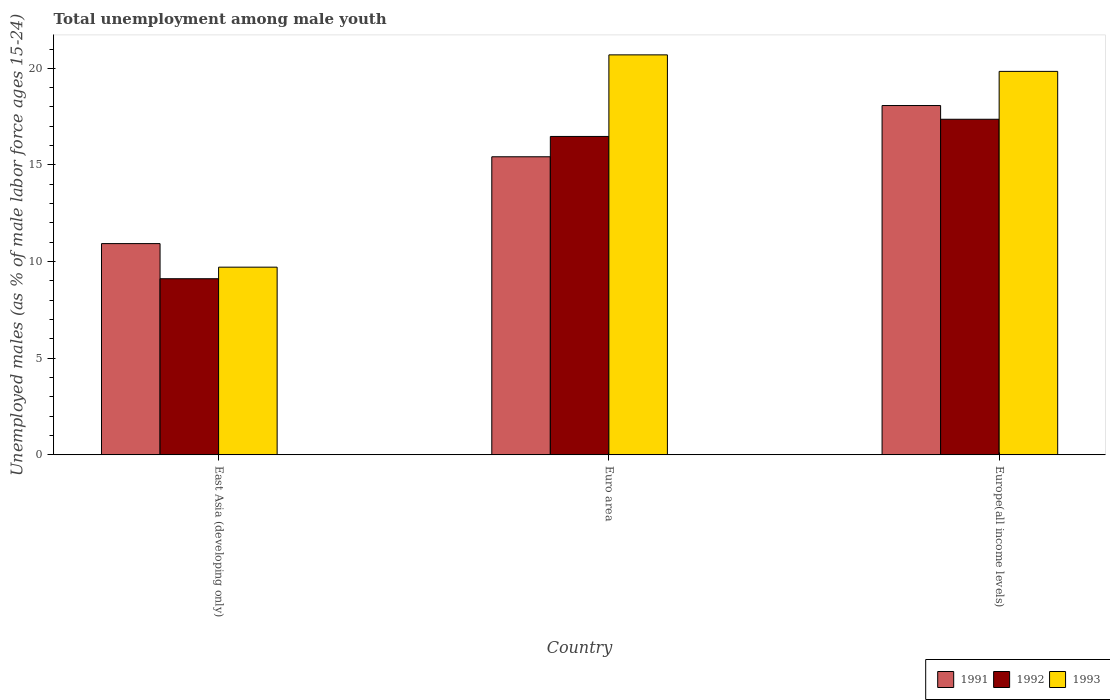How many bars are there on the 3rd tick from the right?
Provide a succinct answer. 3. What is the label of the 3rd group of bars from the left?
Provide a succinct answer. Europe(all income levels). What is the percentage of unemployed males in in 1992 in Euro area?
Your response must be concise. 16.47. Across all countries, what is the maximum percentage of unemployed males in in 1991?
Provide a succinct answer. 18.07. Across all countries, what is the minimum percentage of unemployed males in in 1993?
Provide a succinct answer. 9.71. In which country was the percentage of unemployed males in in 1991 maximum?
Provide a short and direct response. Europe(all income levels). In which country was the percentage of unemployed males in in 1993 minimum?
Your answer should be very brief. East Asia (developing only). What is the total percentage of unemployed males in in 1992 in the graph?
Offer a terse response. 42.95. What is the difference between the percentage of unemployed males in in 1993 in East Asia (developing only) and that in Euro area?
Give a very brief answer. -10.99. What is the difference between the percentage of unemployed males in in 1993 in Euro area and the percentage of unemployed males in in 1991 in Europe(all income levels)?
Offer a terse response. 2.62. What is the average percentage of unemployed males in in 1993 per country?
Ensure brevity in your answer.  16.75. What is the difference between the percentage of unemployed males in of/in 1991 and percentage of unemployed males in of/in 1993 in Euro area?
Offer a terse response. -5.27. In how many countries, is the percentage of unemployed males in in 1993 greater than 6 %?
Provide a succinct answer. 3. What is the ratio of the percentage of unemployed males in in 1991 in East Asia (developing only) to that in Euro area?
Ensure brevity in your answer.  0.71. Is the percentage of unemployed males in in 1991 in East Asia (developing only) less than that in Europe(all income levels)?
Your response must be concise. Yes. What is the difference between the highest and the second highest percentage of unemployed males in in 1993?
Ensure brevity in your answer.  -10.13. What is the difference between the highest and the lowest percentage of unemployed males in in 1992?
Your answer should be compact. 8.25. In how many countries, is the percentage of unemployed males in in 1992 greater than the average percentage of unemployed males in in 1992 taken over all countries?
Offer a very short reply. 2. What does the 1st bar from the left in East Asia (developing only) represents?
Your response must be concise. 1991. How many bars are there?
Your response must be concise. 9. Are all the bars in the graph horizontal?
Offer a terse response. No. Are the values on the major ticks of Y-axis written in scientific E-notation?
Your answer should be compact. No. Does the graph contain any zero values?
Provide a succinct answer. No. Where does the legend appear in the graph?
Provide a short and direct response. Bottom right. How many legend labels are there?
Ensure brevity in your answer.  3. What is the title of the graph?
Provide a short and direct response. Total unemployment among male youth. Does "1961" appear as one of the legend labels in the graph?
Provide a succinct answer. No. What is the label or title of the X-axis?
Your answer should be compact. Country. What is the label or title of the Y-axis?
Give a very brief answer. Unemployed males (as % of male labor force ages 15-24). What is the Unemployed males (as % of male labor force ages 15-24) of 1991 in East Asia (developing only)?
Make the answer very short. 10.93. What is the Unemployed males (as % of male labor force ages 15-24) of 1992 in East Asia (developing only)?
Keep it short and to the point. 9.11. What is the Unemployed males (as % of male labor force ages 15-24) in 1993 in East Asia (developing only)?
Your answer should be compact. 9.71. What is the Unemployed males (as % of male labor force ages 15-24) of 1991 in Euro area?
Your answer should be very brief. 15.42. What is the Unemployed males (as % of male labor force ages 15-24) of 1992 in Euro area?
Make the answer very short. 16.47. What is the Unemployed males (as % of male labor force ages 15-24) of 1993 in Euro area?
Keep it short and to the point. 20.7. What is the Unemployed males (as % of male labor force ages 15-24) of 1991 in Europe(all income levels)?
Keep it short and to the point. 18.07. What is the Unemployed males (as % of male labor force ages 15-24) of 1992 in Europe(all income levels)?
Keep it short and to the point. 17.36. What is the Unemployed males (as % of male labor force ages 15-24) of 1993 in Europe(all income levels)?
Give a very brief answer. 19.84. Across all countries, what is the maximum Unemployed males (as % of male labor force ages 15-24) of 1991?
Provide a short and direct response. 18.07. Across all countries, what is the maximum Unemployed males (as % of male labor force ages 15-24) in 1992?
Your response must be concise. 17.36. Across all countries, what is the maximum Unemployed males (as % of male labor force ages 15-24) of 1993?
Provide a succinct answer. 20.7. Across all countries, what is the minimum Unemployed males (as % of male labor force ages 15-24) of 1991?
Your response must be concise. 10.93. Across all countries, what is the minimum Unemployed males (as % of male labor force ages 15-24) of 1992?
Provide a succinct answer. 9.11. Across all countries, what is the minimum Unemployed males (as % of male labor force ages 15-24) of 1993?
Provide a short and direct response. 9.71. What is the total Unemployed males (as % of male labor force ages 15-24) of 1991 in the graph?
Keep it short and to the point. 44.43. What is the total Unemployed males (as % of male labor force ages 15-24) in 1992 in the graph?
Offer a very short reply. 42.95. What is the total Unemployed males (as % of male labor force ages 15-24) of 1993 in the graph?
Keep it short and to the point. 50.25. What is the difference between the Unemployed males (as % of male labor force ages 15-24) in 1991 in East Asia (developing only) and that in Euro area?
Offer a very short reply. -4.49. What is the difference between the Unemployed males (as % of male labor force ages 15-24) of 1992 in East Asia (developing only) and that in Euro area?
Make the answer very short. -7.36. What is the difference between the Unemployed males (as % of male labor force ages 15-24) in 1993 in East Asia (developing only) and that in Euro area?
Provide a succinct answer. -10.99. What is the difference between the Unemployed males (as % of male labor force ages 15-24) of 1991 in East Asia (developing only) and that in Europe(all income levels)?
Your answer should be compact. -7.14. What is the difference between the Unemployed males (as % of male labor force ages 15-24) of 1992 in East Asia (developing only) and that in Europe(all income levels)?
Give a very brief answer. -8.25. What is the difference between the Unemployed males (as % of male labor force ages 15-24) of 1993 in East Asia (developing only) and that in Europe(all income levels)?
Provide a succinct answer. -10.13. What is the difference between the Unemployed males (as % of male labor force ages 15-24) in 1991 in Euro area and that in Europe(all income levels)?
Your response must be concise. -2.65. What is the difference between the Unemployed males (as % of male labor force ages 15-24) in 1992 in Euro area and that in Europe(all income levels)?
Your answer should be very brief. -0.89. What is the difference between the Unemployed males (as % of male labor force ages 15-24) in 1993 in Euro area and that in Europe(all income levels)?
Provide a succinct answer. 0.85. What is the difference between the Unemployed males (as % of male labor force ages 15-24) of 1991 in East Asia (developing only) and the Unemployed males (as % of male labor force ages 15-24) of 1992 in Euro area?
Your answer should be compact. -5.55. What is the difference between the Unemployed males (as % of male labor force ages 15-24) of 1991 in East Asia (developing only) and the Unemployed males (as % of male labor force ages 15-24) of 1993 in Euro area?
Your response must be concise. -9.77. What is the difference between the Unemployed males (as % of male labor force ages 15-24) of 1992 in East Asia (developing only) and the Unemployed males (as % of male labor force ages 15-24) of 1993 in Euro area?
Your answer should be very brief. -11.58. What is the difference between the Unemployed males (as % of male labor force ages 15-24) of 1991 in East Asia (developing only) and the Unemployed males (as % of male labor force ages 15-24) of 1992 in Europe(all income levels)?
Keep it short and to the point. -6.43. What is the difference between the Unemployed males (as % of male labor force ages 15-24) in 1991 in East Asia (developing only) and the Unemployed males (as % of male labor force ages 15-24) in 1993 in Europe(all income levels)?
Offer a terse response. -8.91. What is the difference between the Unemployed males (as % of male labor force ages 15-24) in 1992 in East Asia (developing only) and the Unemployed males (as % of male labor force ages 15-24) in 1993 in Europe(all income levels)?
Provide a short and direct response. -10.73. What is the difference between the Unemployed males (as % of male labor force ages 15-24) in 1991 in Euro area and the Unemployed males (as % of male labor force ages 15-24) in 1992 in Europe(all income levels)?
Your answer should be very brief. -1.94. What is the difference between the Unemployed males (as % of male labor force ages 15-24) in 1991 in Euro area and the Unemployed males (as % of male labor force ages 15-24) in 1993 in Europe(all income levels)?
Offer a very short reply. -4.42. What is the difference between the Unemployed males (as % of male labor force ages 15-24) in 1992 in Euro area and the Unemployed males (as % of male labor force ages 15-24) in 1993 in Europe(all income levels)?
Provide a short and direct response. -3.37. What is the average Unemployed males (as % of male labor force ages 15-24) in 1991 per country?
Make the answer very short. 14.81. What is the average Unemployed males (as % of male labor force ages 15-24) of 1992 per country?
Offer a very short reply. 14.32. What is the average Unemployed males (as % of male labor force ages 15-24) in 1993 per country?
Keep it short and to the point. 16.75. What is the difference between the Unemployed males (as % of male labor force ages 15-24) of 1991 and Unemployed males (as % of male labor force ages 15-24) of 1992 in East Asia (developing only)?
Ensure brevity in your answer.  1.82. What is the difference between the Unemployed males (as % of male labor force ages 15-24) of 1991 and Unemployed males (as % of male labor force ages 15-24) of 1993 in East Asia (developing only)?
Provide a succinct answer. 1.22. What is the difference between the Unemployed males (as % of male labor force ages 15-24) in 1992 and Unemployed males (as % of male labor force ages 15-24) in 1993 in East Asia (developing only)?
Give a very brief answer. -0.6. What is the difference between the Unemployed males (as % of male labor force ages 15-24) of 1991 and Unemployed males (as % of male labor force ages 15-24) of 1992 in Euro area?
Offer a terse response. -1.05. What is the difference between the Unemployed males (as % of male labor force ages 15-24) in 1991 and Unemployed males (as % of male labor force ages 15-24) in 1993 in Euro area?
Your answer should be compact. -5.27. What is the difference between the Unemployed males (as % of male labor force ages 15-24) of 1992 and Unemployed males (as % of male labor force ages 15-24) of 1993 in Euro area?
Ensure brevity in your answer.  -4.22. What is the difference between the Unemployed males (as % of male labor force ages 15-24) in 1991 and Unemployed males (as % of male labor force ages 15-24) in 1992 in Europe(all income levels)?
Offer a very short reply. 0.71. What is the difference between the Unemployed males (as % of male labor force ages 15-24) in 1991 and Unemployed males (as % of male labor force ages 15-24) in 1993 in Europe(all income levels)?
Offer a terse response. -1.77. What is the difference between the Unemployed males (as % of male labor force ages 15-24) in 1992 and Unemployed males (as % of male labor force ages 15-24) in 1993 in Europe(all income levels)?
Give a very brief answer. -2.48. What is the ratio of the Unemployed males (as % of male labor force ages 15-24) in 1991 in East Asia (developing only) to that in Euro area?
Make the answer very short. 0.71. What is the ratio of the Unemployed males (as % of male labor force ages 15-24) in 1992 in East Asia (developing only) to that in Euro area?
Offer a terse response. 0.55. What is the ratio of the Unemployed males (as % of male labor force ages 15-24) in 1993 in East Asia (developing only) to that in Euro area?
Your response must be concise. 0.47. What is the ratio of the Unemployed males (as % of male labor force ages 15-24) in 1991 in East Asia (developing only) to that in Europe(all income levels)?
Provide a succinct answer. 0.6. What is the ratio of the Unemployed males (as % of male labor force ages 15-24) in 1992 in East Asia (developing only) to that in Europe(all income levels)?
Keep it short and to the point. 0.52. What is the ratio of the Unemployed males (as % of male labor force ages 15-24) of 1993 in East Asia (developing only) to that in Europe(all income levels)?
Provide a short and direct response. 0.49. What is the ratio of the Unemployed males (as % of male labor force ages 15-24) of 1991 in Euro area to that in Europe(all income levels)?
Give a very brief answer. 0.85. What is the ratio of the Unemployed males (as % of male labor force ages 15-24) of 1992 in Euro area to that in Europe(all income levels)?
Give a very brief answer. 0.95. What is the ratio of the Unemployed males (as % of male labor force ages 15-24) in 1993 in Euro area to that in Europe(all income levels)?
Keep it short and to the point. 1.04. What is the difference between the highest and the second highest Unemployed males (as % of male labor force ages 15-24) of 1991?
Provide a short and direct response. 2.65. What is the difference between the highest and the second highest Unemployed males (as % of male labor force ages 15-24) of 1992?
Provide a short and direct response. 0.89. What is the difference between the highest and the second highest Unemployed males (as % of male labor force ages 15-24) in 1993?
Provide a succinct answer. 0.85. What is the difference between the highest and the lowest Unemployed males (as % of male labor force ages 15-24) in 1991?
Provide a succinct answer. 7.14. What is the difference between the highest and the lowest Unemployed males (as % of male labor force ages 15-24) of 1992?
Your answer should be compact. 8.25. What is the difference between the highest and the lowest Unemployed males (as % of male labor force ages 15-24) of 1993?
Provide a short and direct response. 10.99. 